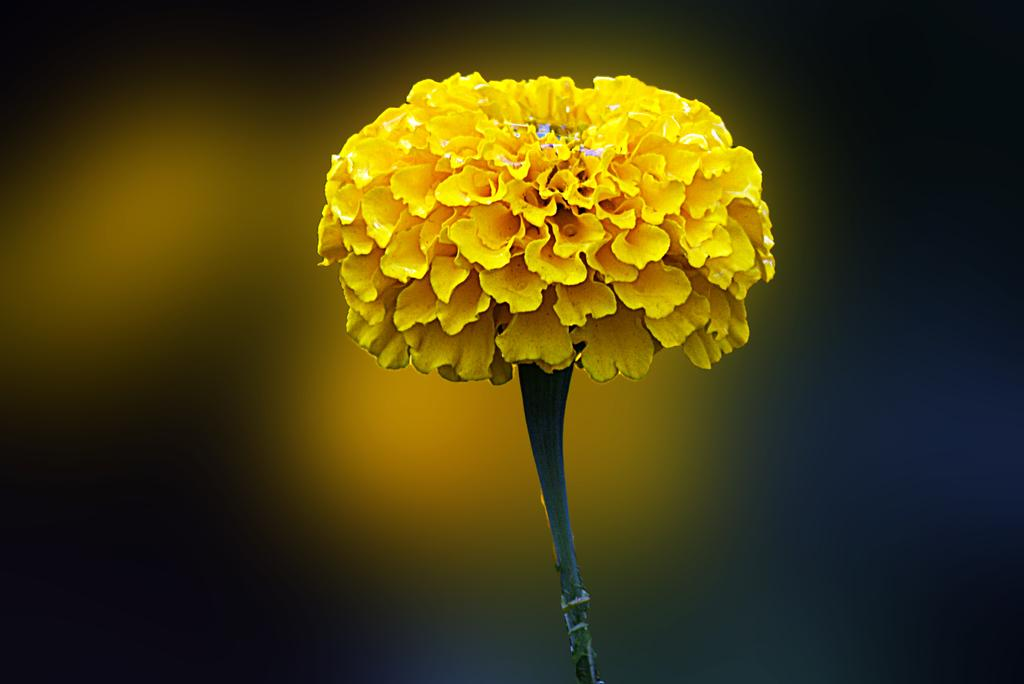What type of photography is used in the image? The image is a macro photography. What is the main subject of the macro photography? The subject of the macro photography is a flower. How is the background of the image depicted? The background of the image is blurred. Can you tell me how many drains are visible in the image? There are no drains present in the image, as it features a macro photograph of a flower. What type of plane can be seen flying in the background of the image? There is no plane visible in the image, as it is a macro photograph of a flower with a blurred background. 